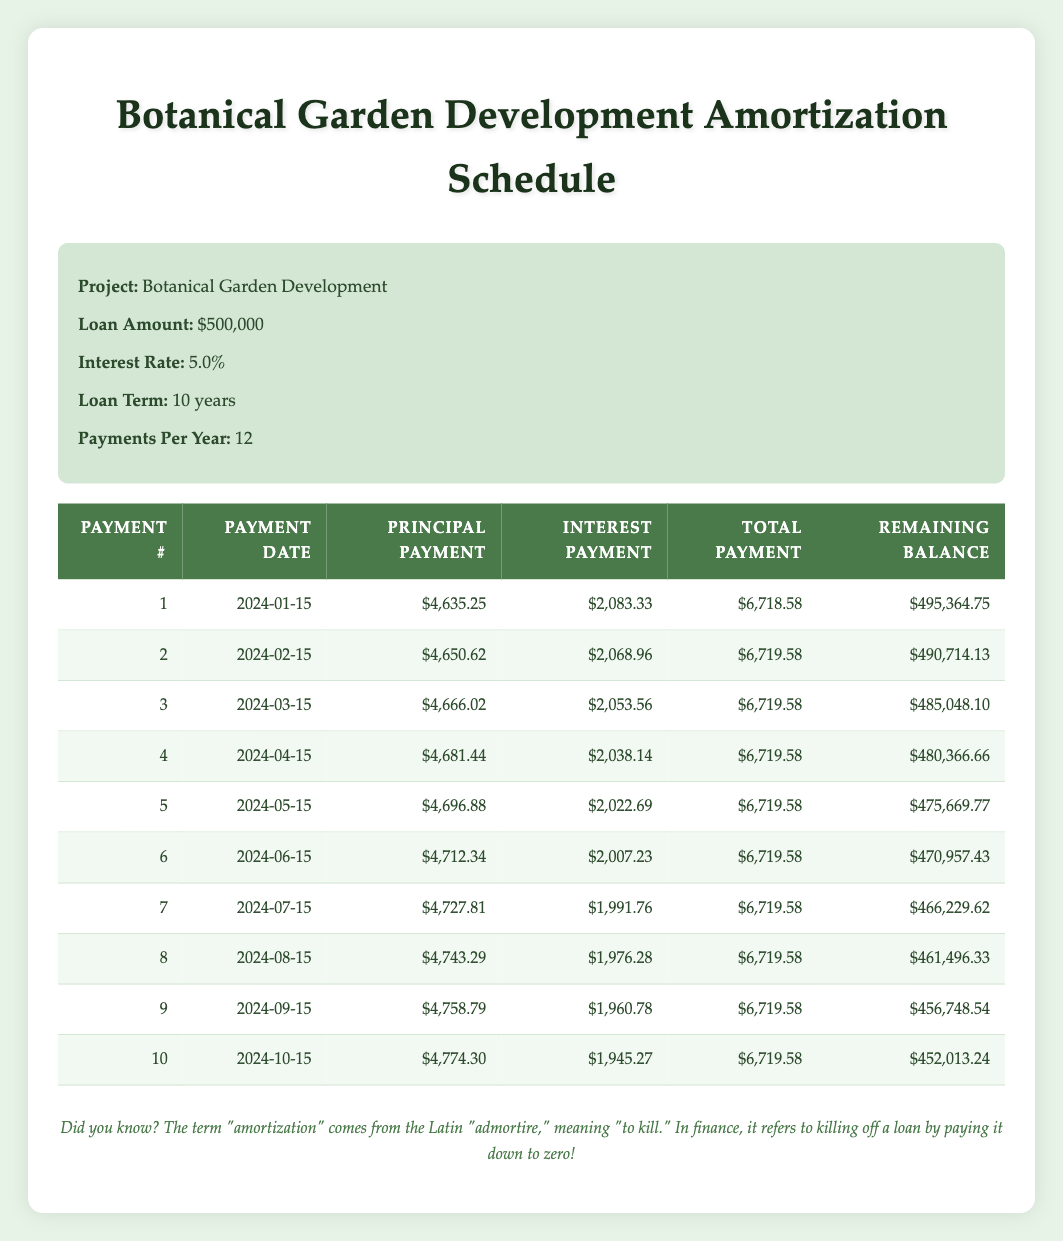What is the total payment for the first month? The total payment for the first month is provided in the table under the "Total Payment" column for payment number 1, which is $6,718.58.
Answer: $6,718.58 How much was the principal payment in the third month? The principal payment for the third month can be found in the "Principal Payment" column for payment number 3, which is $4,666.02.
Answer: $4,666.02 Is the interest payment decreasing over the months? Observing the "Interest Payment" column, the values start at $2,083.33 and decrease to $1,945.27 by the tenth payment, indicating a downward trend. Therefore, the interest payment is indeed decreasing over the months.
Answer: Yes What is the remaining balance after the fifth payment? To find the remaining balance after the fifth payment, we refer to the row for payment number 5 in the "Remaining Balance" column, which shows a remaining balance of $475,669.77.
Answer: $475,669.77 What is the average principal payment over the first ten payments? First, we sum the principal payments for the ten payments: (4635.25 + 4650.62 + 4666.02 + 4681.44 + 4696.88 + 4712.34 + 4727.81 + 4743.29 + 4758.79 + 4774.30) = $47,986.74. Then we divide this sum by 10 to find the average: $47,986.74 / 10 = $4,798.67.
Answer: $4,798.67 How much total interest was paid in the first two months combined? To find the total interest paid in the first two months, we add the interest payments for payment numbers 1 and 2: $2,083.33 + $2,068.96 = $4,152.29.
Answer: $4,152.29 After which payment is the remaining loan balance below $460,000? By inspecting the "Remaining Balance" column, we see that the balance drops below $460,000 after the ninth payment (the remaining balance after the ninth payment is $456,748.54). Therefore, this occurs after payment number 9.
Answer: Payment number 9 What is the difference in the total payments between the first and last payments? The first payment total is $6,718.58 and the last payment total is $6,719.58. The difference is $6,719.58 - $6,718.58 = $1.
Answer: $1 What was the total loan amount for the project? The total loan amount is stated in the project information section and is $500,000.
Answer: $500,000 